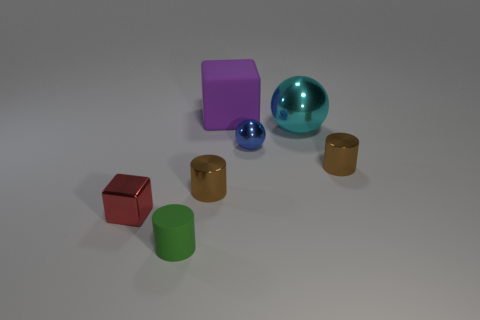Subtract all metallic cylinders. How many cylinders are left? 1 Add 1 metal cylinders. How many objects exist? 8 Subtract all green cylinders. How many cylinders are left? 2 Subtract all blocks. How many objects are left? 5 Add 2 large yellow rubber balls. How many large yellow rubber balls exist? 2 Subtract 0 yellow cubes. How many objects are left? 7 Subtract 1 balls. How many balls are left? 1 Subtract all red spheres. Subtract all purple blocks. How many spheres are left? 2 Subtract all green cylinders. How many blue spheres are left? 1 Subtract all big spheres. Subtract all small green matte things. How many objects are left? 5 